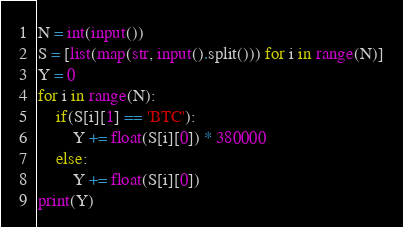<code> <loc_0><loc_0><loc_500><loc_500><_Python_>N = int(input())
S = [list(map(str, input().split())) for i in range(N)]
Y = 0
for i in range(N):
    if(S[i][1] == 'BTC'):
        Y += float(S[i][0]) * 380000
    else:
        Y += float(S[i][0])
print(Y)
</code> 